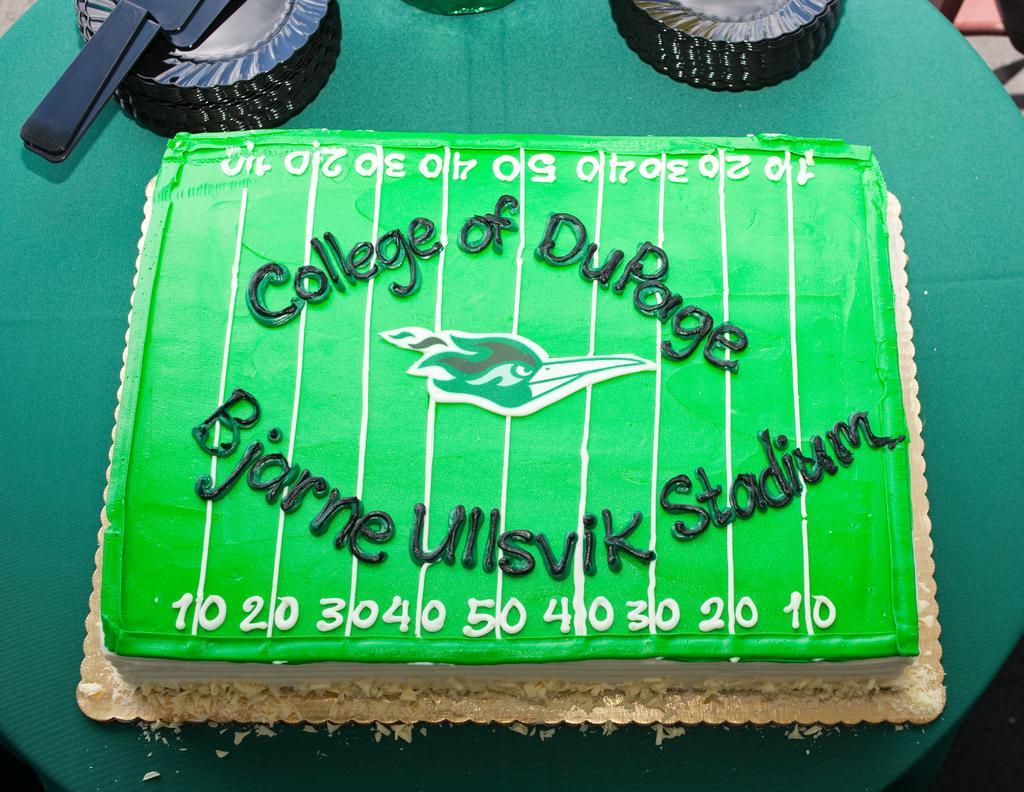Please provide a concise description of this image. In this image I can see there is a cake and there are few things on this table. There is the text on this cake. 